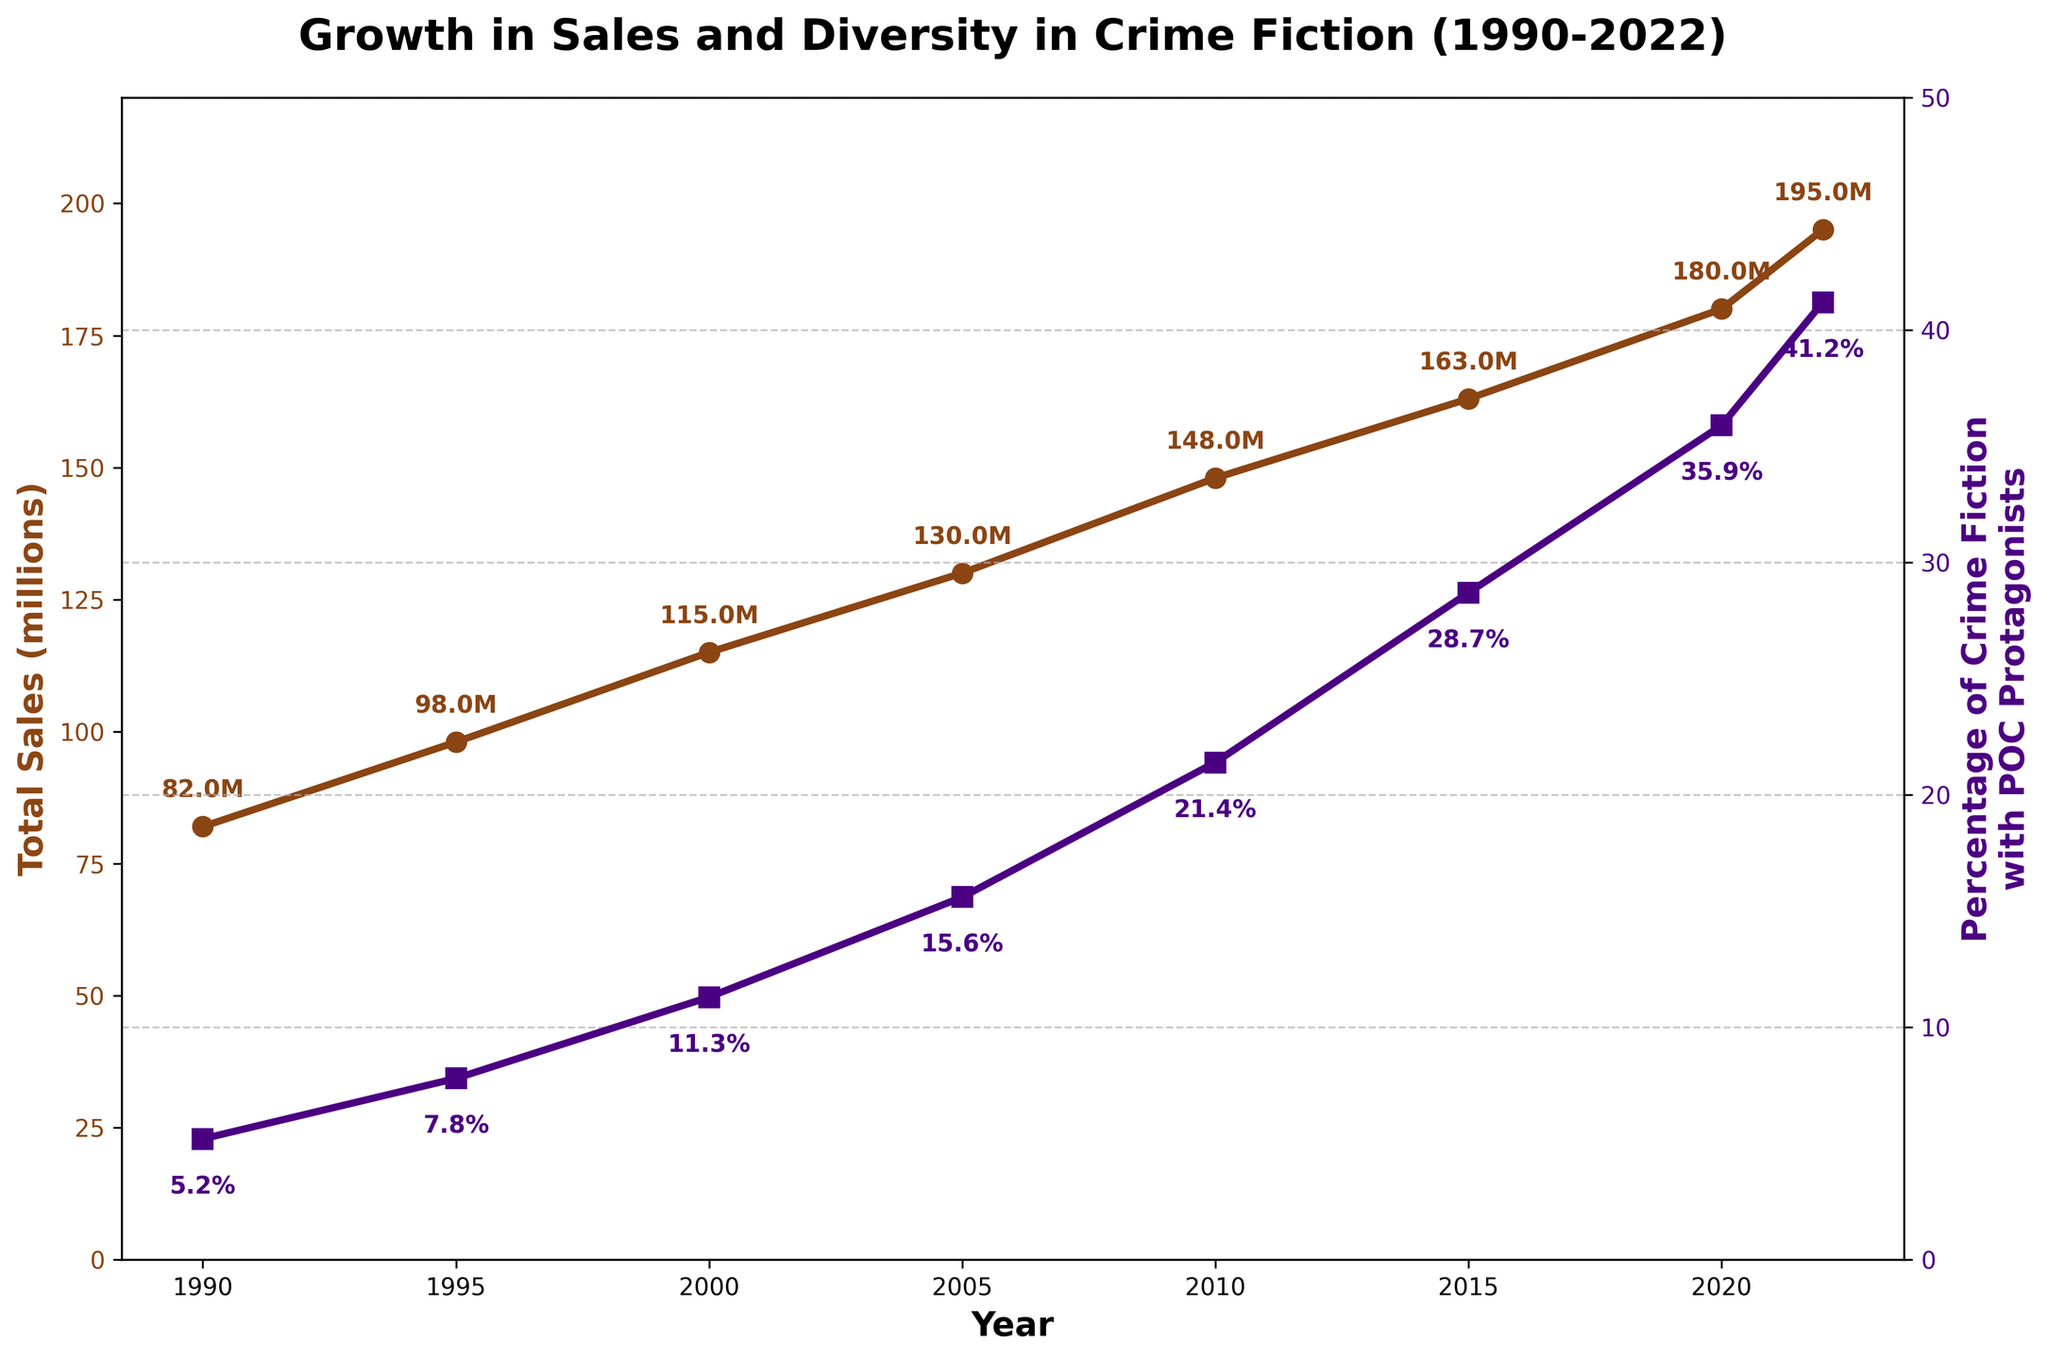What is the total sales (in millions) for the year 2000? Find the point associated with the year 2000 on the left y-axis (Total Sales) and read the value.
Answer: 115 What is the percentage of crime fiction with POC protagonists in 2015? Find the point associated with the year 2015 on the right y-axis (Percentage of Crime Fiction with POC Protagonists) and read the value.
Answer: 28.7% How much did the total sales (in millions) increase from 1995 to 2005? Subtract the total sales in 1995 from the total sales in 2005: 130 - 98 = 32
Answer: 32 What is the average percentage of crime fiction with POC protagonists over the years 2000, 2005, and 2010? Calculate the average by summing the percentages for 2000, 2005, and 2010 and dividing by 3: (11.3 + 15.6 + 21.4) / 3 = 16.1
Answer: 16.1% By how much did the percentage of crime fiction with POC protagonists increase from 1990 to 2022? Subtract the percentage in 1990 from the percentage in 2022: 41.2 - 5.2 = 36
Answer: 36 Which year had the highest total sales? Find the year that corresponds to the highest point on the left y-axis (Total Sales).
Answer: 2022 In which decade did the percentage of crime fiction with POC protagonists show the greatest increase? Calculate the increase for each decade: 1990 to 2000 (11.3 - 5.2 = 6.1), 2000 to 2010 (21.4 - 11.3 = 10.1), 2010 to 2020 (35.9 - 21.4 = 14.5), and 2020 to 2022 (41.2 - 35.9 = 5.3). The greatest increase is from 2010 to 2020.
Answer: 2010 to 2020 What is the overall trend in total sales from 1990 to 2022? Look at the plot for Total Sales on the left y-axis and observe if it is generally increasing or decreasing. The trend is increasing.
Answer: Increasing Compare the rate of change in total sales and the percentage of crime fiction with POC protagonists from 2000 to 2020. Which grew faster? Calculate the rate of change for both metrics between 2000 and 2020: Total Sales: (180 - 115) / 20 = 3.25 per year; Percentage: (35.9 - 11.3) / 20 = 1.23 per year. The percentage of crime fiction with POC protagonists grew faster.
Answer: Percentage of crime fiction with POC protagonists What is the difference in the percentage of crime fiction with POC protagonists between 2005 and 2015? Subtract the percentage in 2005 from the percentage in 2015: 28.7 - 15.6 = 13.1
Answer: 13.1 